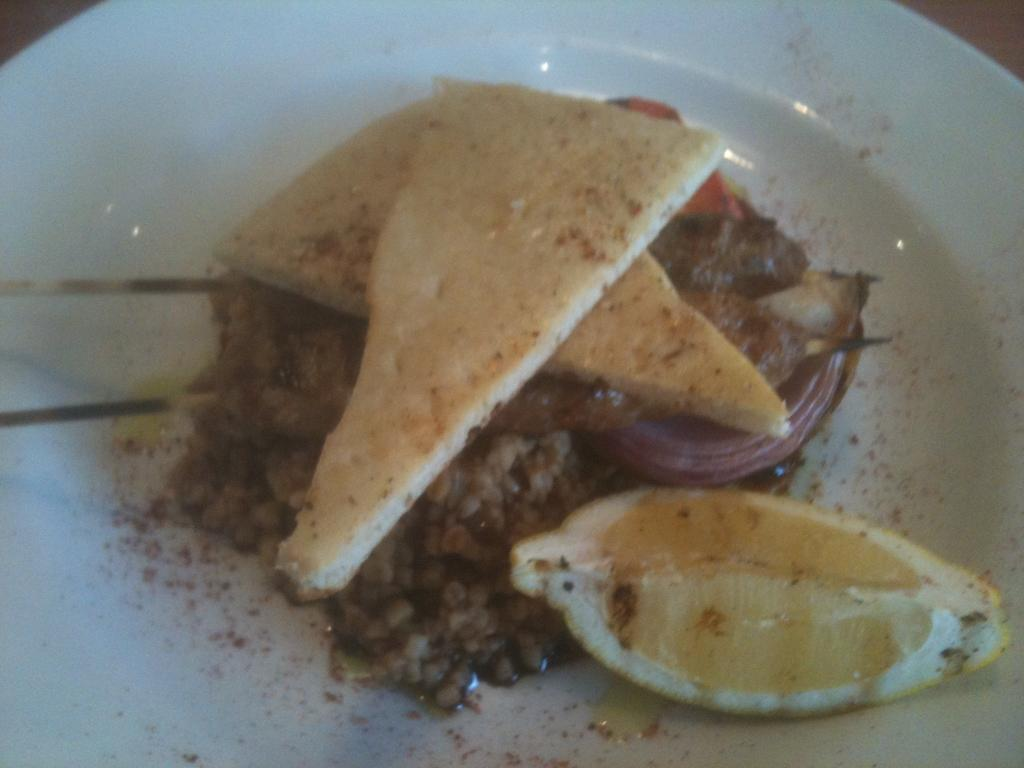What is present on the plate in the image? There are food items on the plate in the image. What type of drum is being played during the feast in the image? There is no feast or drum present in the image; it only features a plate with food items. 